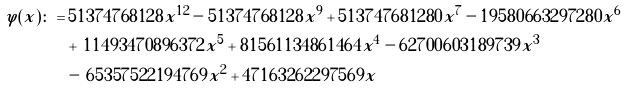<formula> <loc_0><loc_0><loc_500><loc_500>\varphi ( x ) \colon = & \, 5 1 3 7 4 7 6 8 1 2 8 x ^ { 1 2 } - 5 1 3 7 4 7 6 8 1 2 8 x ^ { 9 } + 5 1 3 7 4 7 6 8 1 2 8 0 x ^ { 7 } - 1 9 5 8 0 6 6 3 2 9 7 2 8 0 x ^ { 6 } \\ & + \, 1 1 4 9 3 4 7 0 8 9 6 3 7 2 x ^ { 5 } + 8 1 5 6 1 1 3 4 8 6 1 4 6 4 x ^ { 4 } - 6 2 7 0 0 6 0 3 1 8 9 7 3 9 x ^ { 3 } \\ & - \, 6 5 3 5 7 5 2 2 1 9 4 7 6 9 x ^ { 2 } + 4 7 1 6 3 2 6 2 2 9 7 5 6 9 x</formula> 